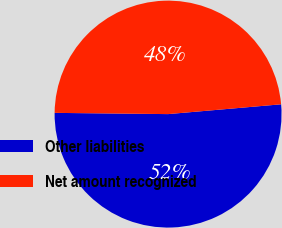Convert chart. <chart><loc_0><loc_0><loc_500><loc_500><pie_chart><fcel>Other liabilities<fcel>Net amount recognized<nl><fcel>51.55%<fcel>48.45%<nl></chart> 